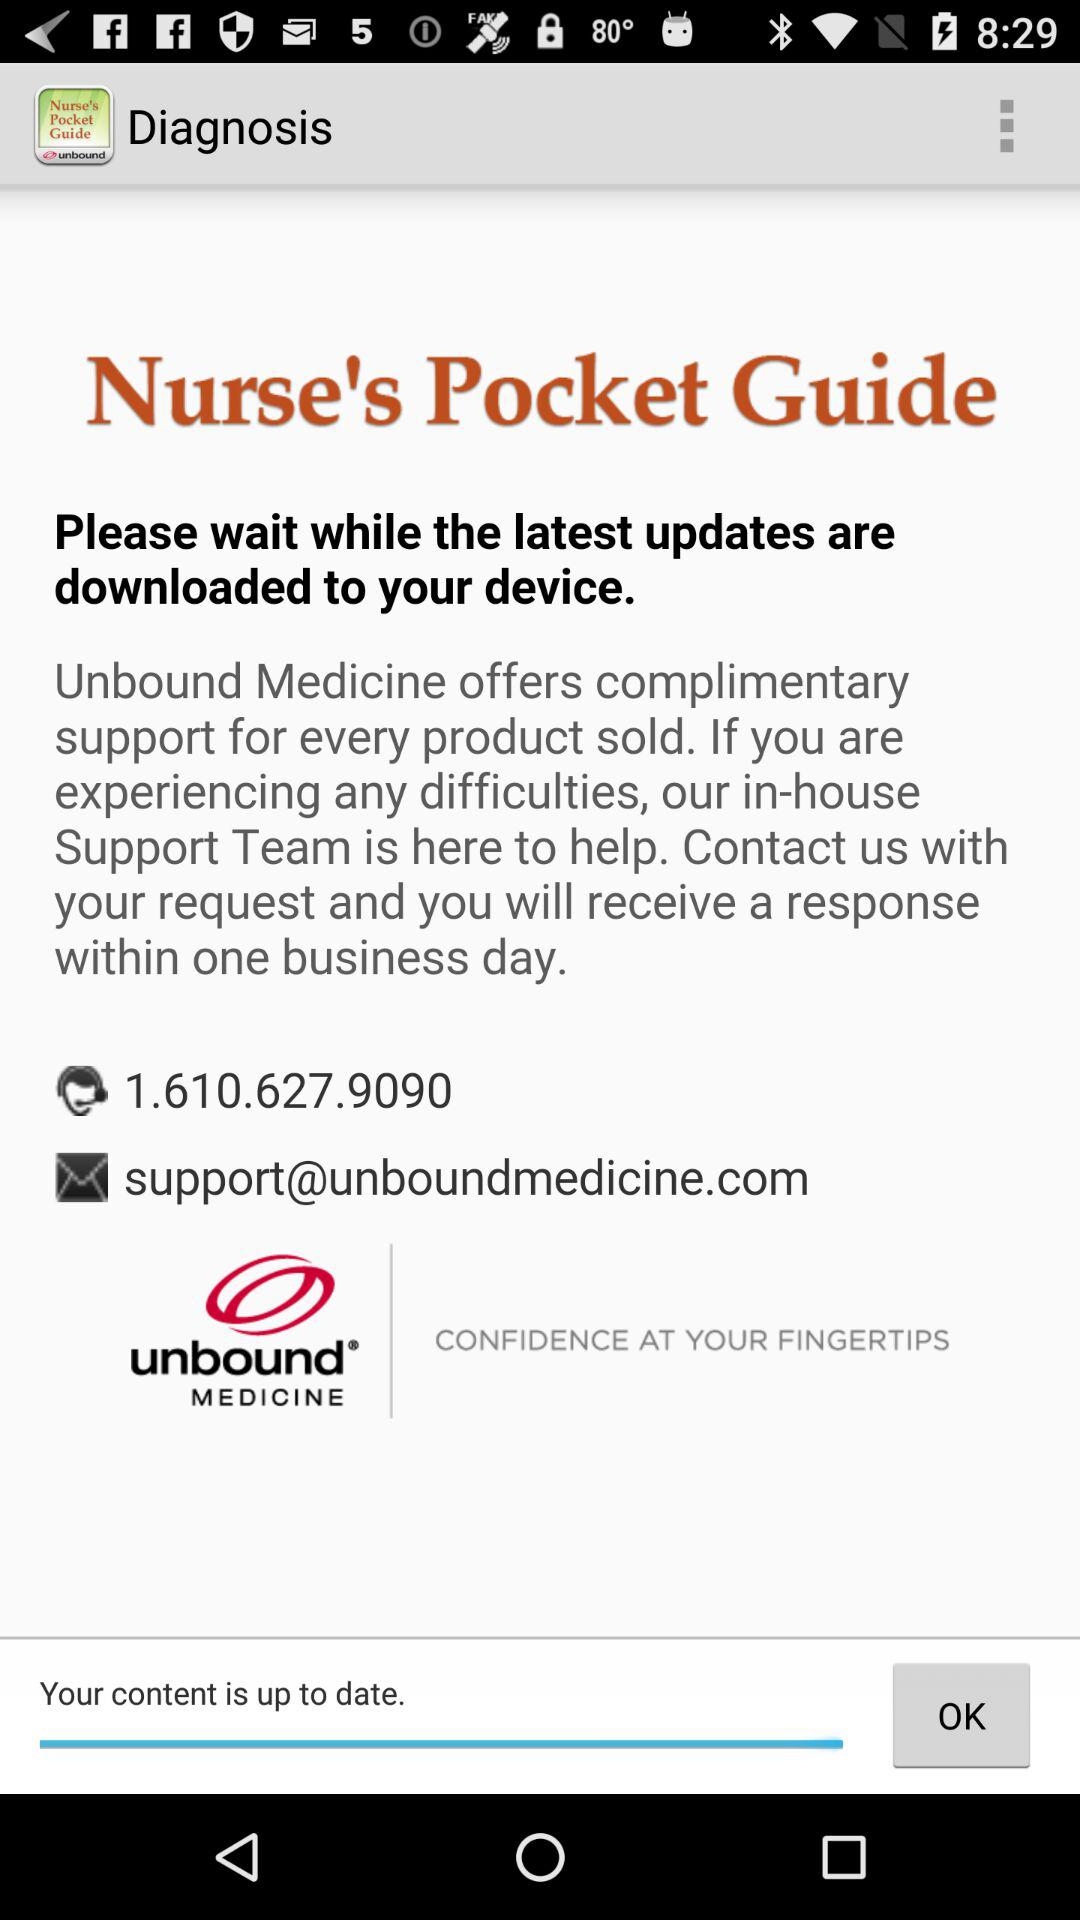What is the application name? The application name is "Nurse's Pocket Guide - Diagnos". 